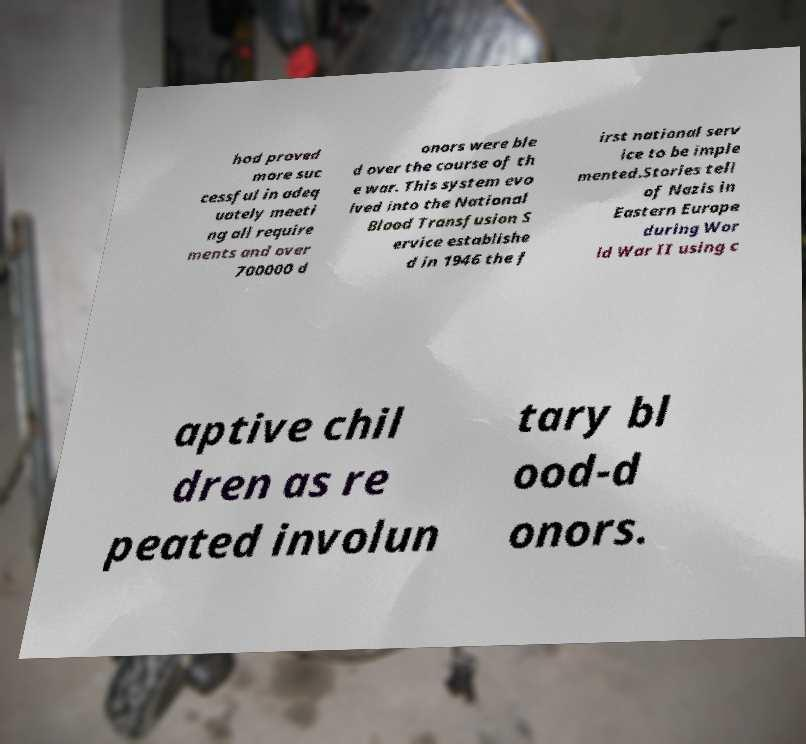Can you read and provide the text displayed in the image?This photo seems to have some interesting text. Can you extract and type it out for me? hod proved more suc cessful in adeq uately meeti ng all require ments and over 700000 d onors were ble d over the course of th e war. This system evo lved into the National Blood Transfusion S ervice establishe d in 1946 the f irst national serv ice to be imple mented.Stories tell of Nazis in Eastern Europe during Wor ld War II using c aptive chil dren as re peated involun tary bl ood-d onors. 